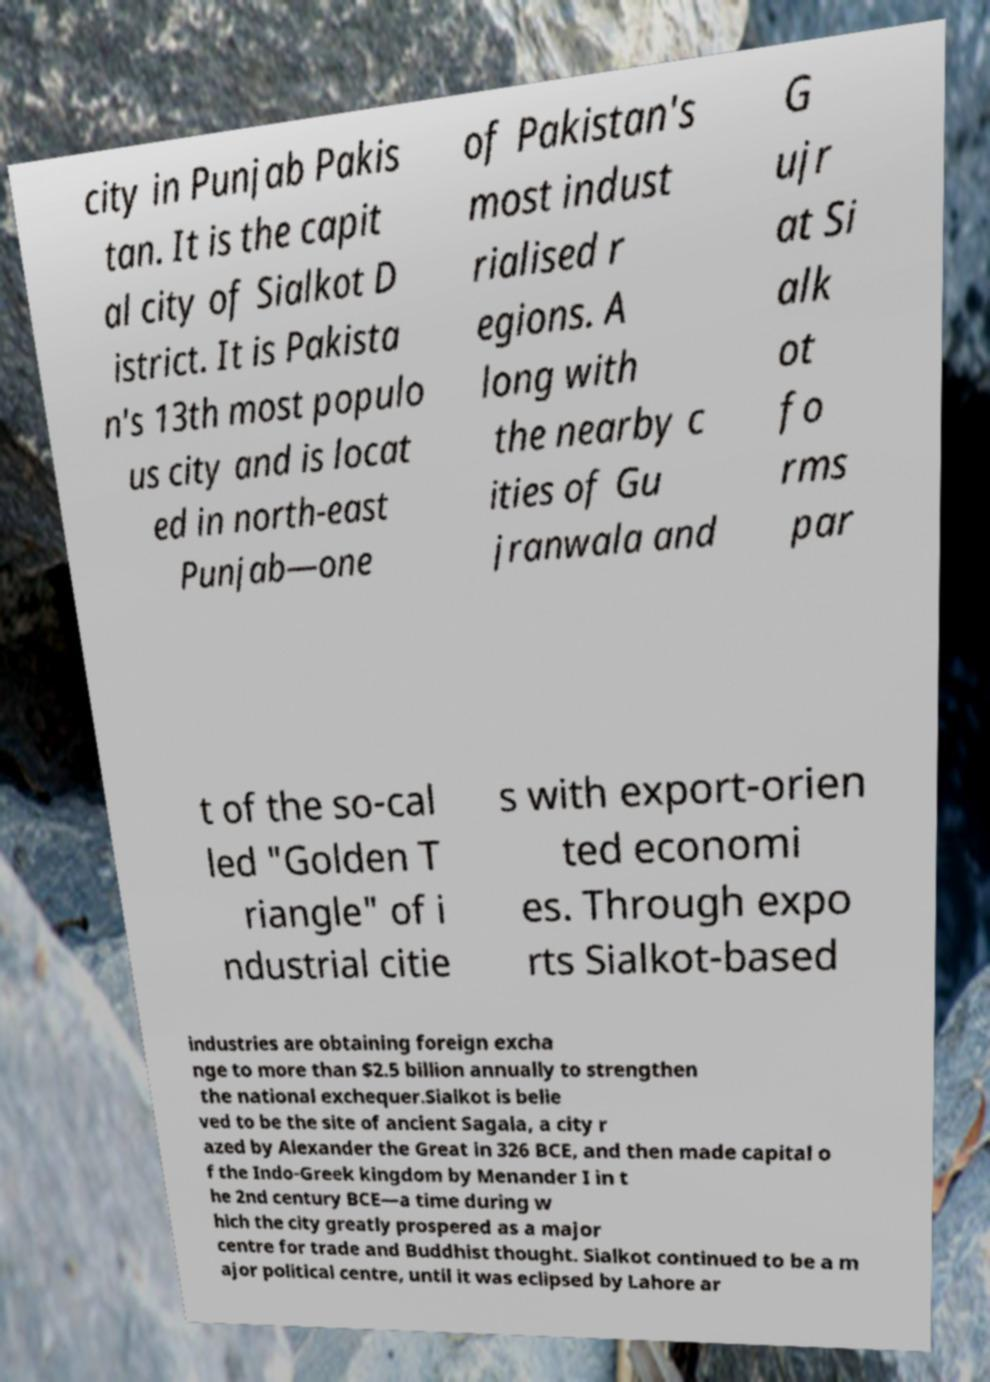Could you extract and type out the text from this image? city in Punjab Pakis tan. It is the capit al city of Sialkot D istrict. It is Pakista n's 13th most populo us city and is locat ed in north-east Punjab—one of Pakistan's most indust rialised r egions. A long with the nearby c ities of Gu jranwala and G ujr at Si alk ot fo rms par t of the so-cal led "Golden T riangle" of i ndustrial citie s with export-orien ted economi es. Through expo rts Sialkot-based industries are obtaining foreign excha nge to more than $2.5 billion annually to strengthen the national exchequer.Sialkot is belie ved to be the site of ancient Sagala, a city r azed by Alexander the Great in 326 BCE, and then made capital o f the Indo-Greek kingdom by Menander I in t he 2nd century BCE—a time during w hich the city greatly prospered as a major centre for trade and Buddhist thought. Sialkot continued to be a m ajor political centre, until it was eclipsed by Lahore ar 